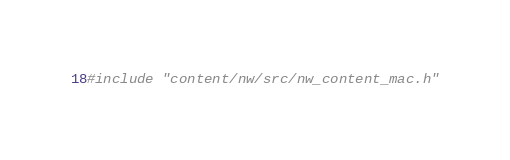Convert code to text. <code><loc_0><loc_0><loc_500><loc_500><_ObjectiveC_>#include "content/nw/src/nw_content_mac.h"
</code> 